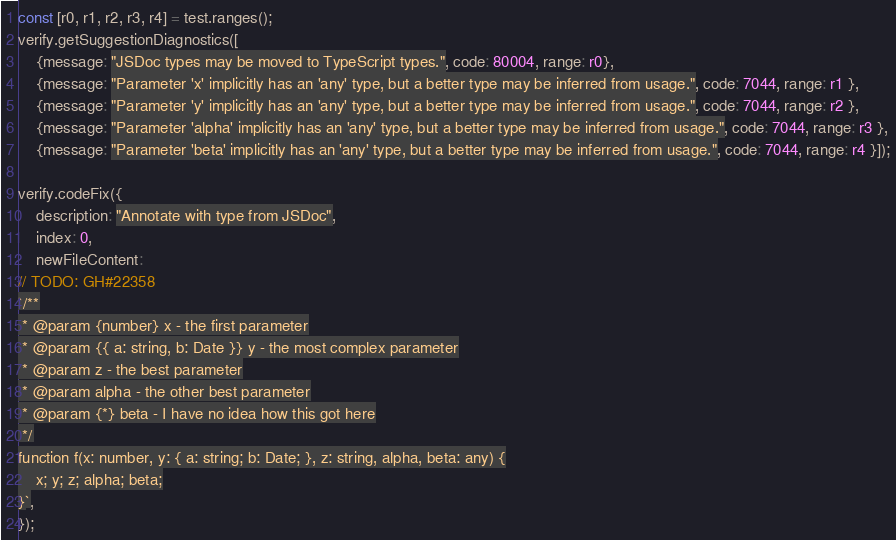<code> <loc_0><loc_0><loc_500><loc_500><_TypeScript_>
const [r0, r1, r2, r3, r4] = test.ranges();
verify.getSuggestionDiagnostics([
    {message: "JSDoc types may be moved to TypeScript types.", code: 80004, range: r0},
    {message: "Parameter 'x' implicitly has an 'any' type, but a better type may be inferred from usage.", code: 7044, range: r1 },
    {message: "Parameter 'y' implicitly has an 'any' type, but a better type may be inferred from usage.", code: 7044, range: r2 },
    {message: "Parameter 'alpha' implicitly has an 'any' type, but a better type may be inferred from usage.", code: 7044, range: r3 },
    {message: "Parameter 'beta' implicitly has an 'any' type, but a better type may be inferred from usage.", code: 7044, range: r4 }]);

verify.codeFix({
    description: "Annotate with type from JSDoc",
    index: 0,
    newFileContent:
// TODO: GH#22358
`/**
 * @param {number} x - the first parameter
 * @param {{ a: string, b: Date }} y - the most complex parameter
 * @param z - the best parameter
 * @param alpha - the other best parameter
 * @param {*} beta - I have no idea how this got here
 */
function f(x: number, y: { a: string; b: Date; }, z: string, alpha, beta: any) {
    x; y; z; alpha; beta;
}`,
});
</code> 